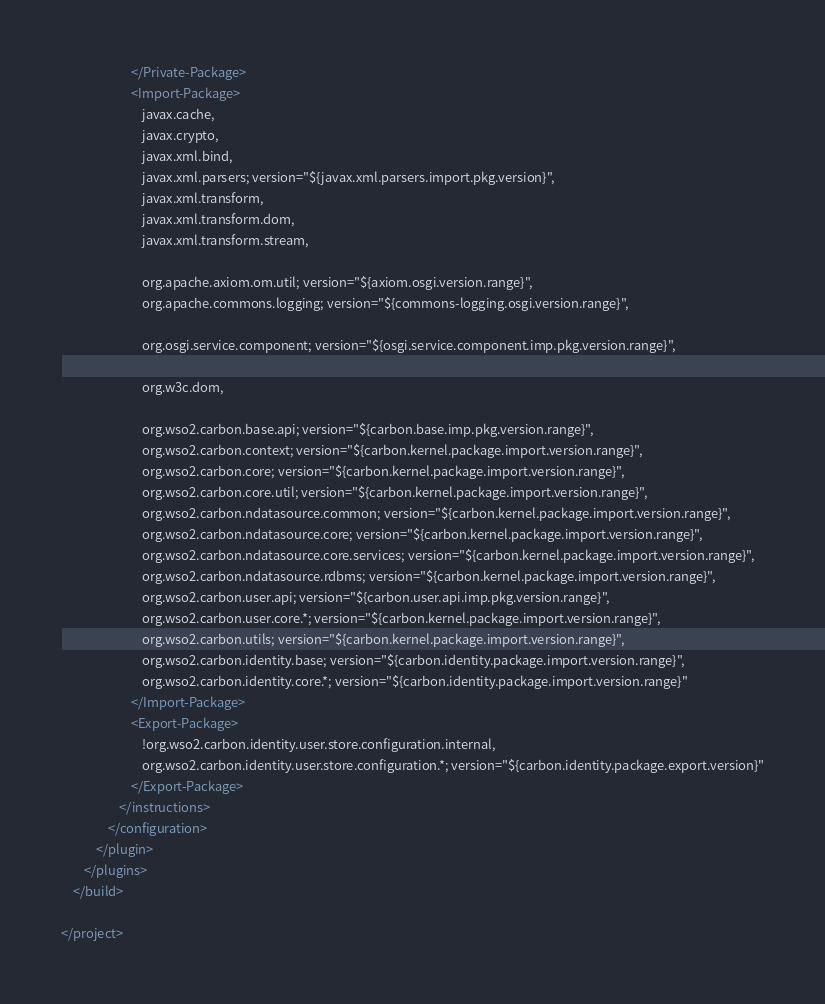<code> <loc_0><loc_0><loc_500><loc_500><_XML_>                        </Private-Package>
                        <Import-Package>
                            javax.cache,
                            javax.crypto,
                            javax.xml.bind,
                            javax.xml.parsers; version="${javax.xml.parsers.import.pkg.version}",
                            javax.xml.transform,
                            javax.xml.transform.dom,
                            javax.xml.transform.stream,

                            org.apache.axiom.om.util; version="${axiom.osgi.version.range}",
                            org.apache.commons.logging; version="${commons-logging.osgi.version.range}",

                            org.osgi.service.component; version="${osgi.service.component.imp.pkg.version.range}",

                            org.w3c.dom,

                            org.wso2.carbon.base.api; version="${carbon.base.imp.pkg.version.range}",
                            org.wso2.carbon.context; version="${carbon.kernel.package.import.version.range}",
                            org.wso2.carbon.core; version="${carbon.kernel.package.import.version.range}",
                            org.wso2.carbon.core.util; version="${carbon.kernel.package.import.version.range}",
                            org.wso2.carbon.ndatasource.common; version="${carbon.kernel.package.import.version.range}",
                            org.wso2.carbon.ndatasource.core; version="${carbon.kernel.package.import.version.range}",
                            org.wso2.carbon.ndatasource.core.services; version="${carbon.kernel.package.import.version.range}",
                            org.wso2.carbon.ndatasource.rdbms; version="${carbon.kernel.package.import.version.range}",
                            org.wso2.carbon.user.api; version="${carbon.user.api.imp.pkg.version.range}",
                            org.wso2.carbon.user.core.*; version="${carbon.kernel.package.import.version.range}",
                            org.wso2.carbon.utils; version="${carbon.kernel.package.import.version.range}",
                            org.wso2.carbon.identity.base; version="${carbon.identity.package.import.version.range}",
                            org.wso2.carbon.identity.core.*; version="${carbon.identity.package.import.version.range}"
                        </Import-Package>
                        <Export-Package>
                            !org.wso2.carbon.identity.user.store.configuration.internal,
                            org.wso2.carbon.identity.user.store.configuration.*; version="${carbon.identity.package.export.version}"
                        </Export-Package>
                    </instructions>
                </configuration>
            </plugin>
        </plugins>
    </build>

</project>
</code> 